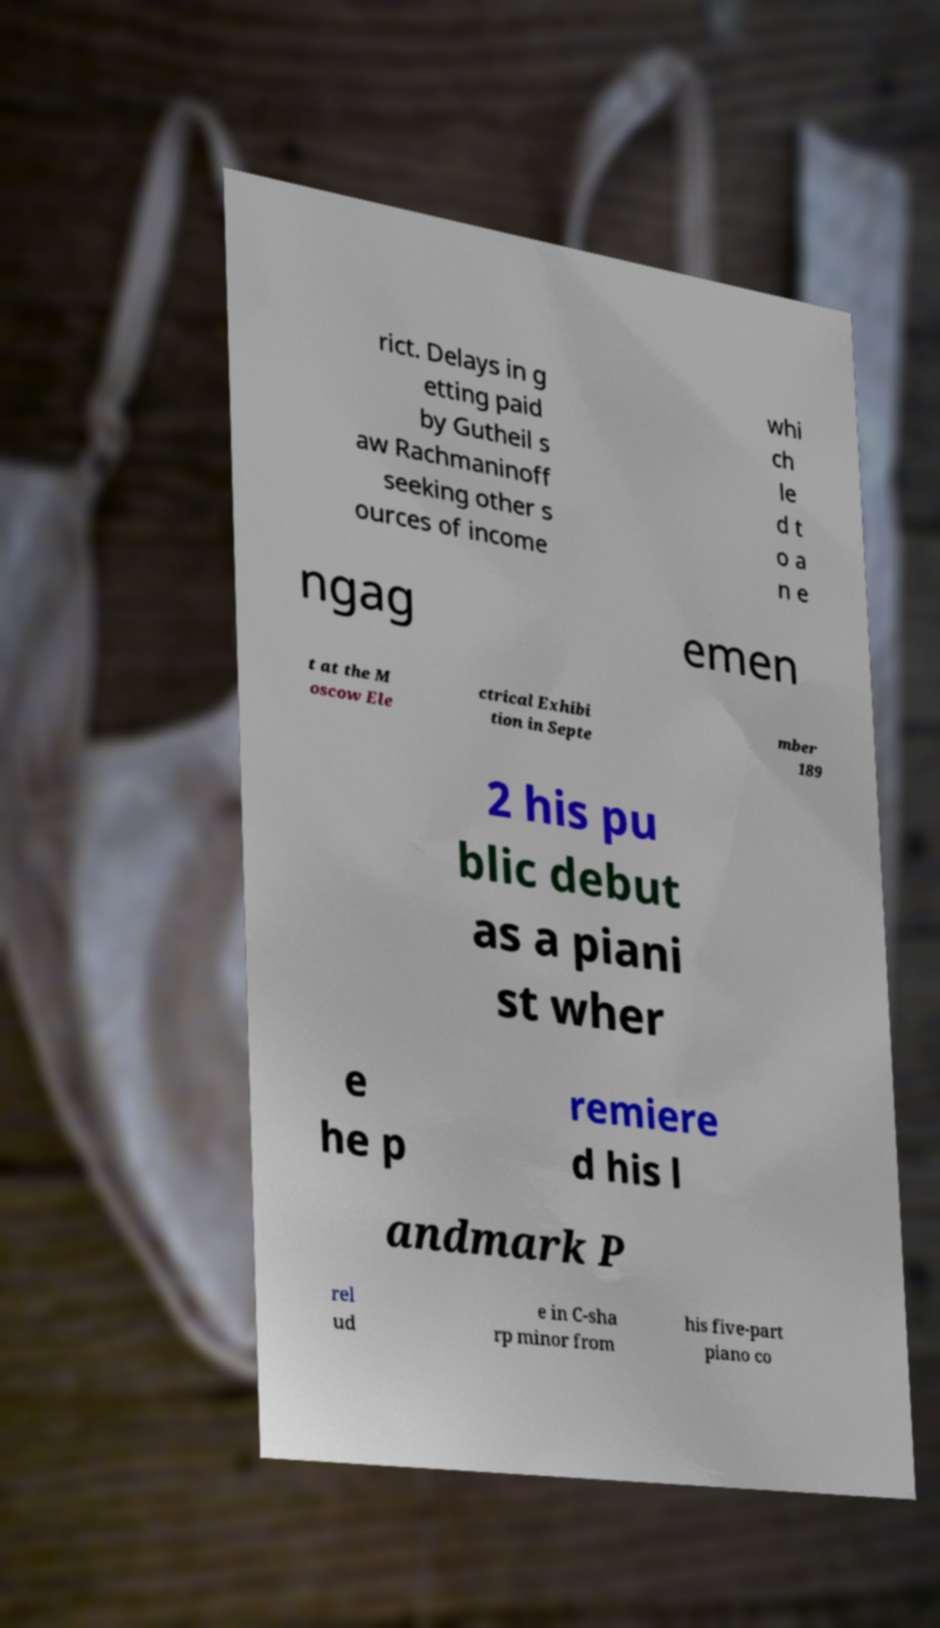Can you accurately transcribe the text from the provided image for me? rict. Delays in g etting paid by Gutheil s aw Rachmaninoff seeking other s ources of income whi ch le d t o a n e ngag emen t at the M oscow Ele ctrical Exhibi tion in Septe mber 189 2 his pu blic debut as a piani st wher e he p remiere d his l andmark P rel ud e in C-sha rp minor from his five-part piano co 